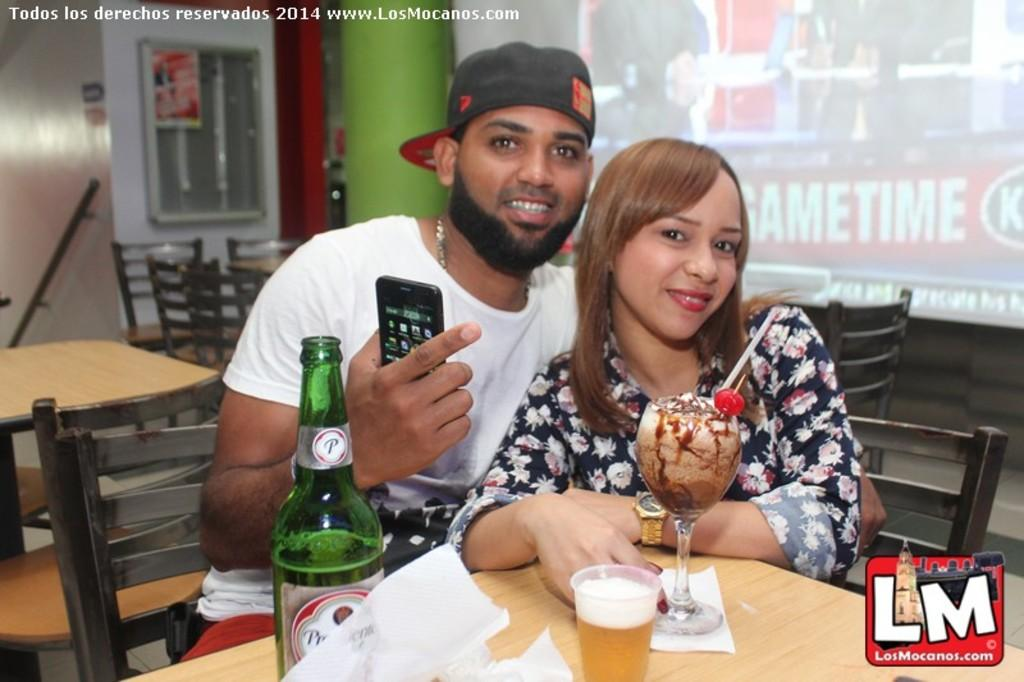How many people are in the image? There are two persons in the image. What are the two persons doing in the image? The two persons are sitting on chairs and hugging each other. What objects can be seen on the table in the image? There is a bottle glass and ice cream on the table. What type of board is being used by the two persons in the image? There is no board present in the image; the two persons are hugging each other while sitting on chairs. 